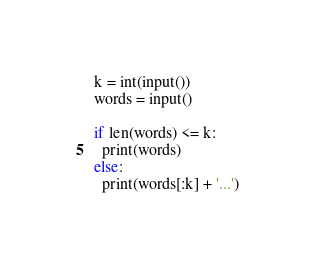<code> <loc_0><loc_0><loc_500><loc_500><_Python_>k = int(input())
words = input()

if len(words) <= k:
  print(words)
else:
  print(words[:k] + '...')</code> 